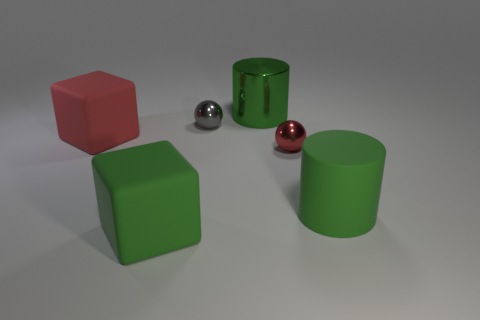Can you describe the lighting in this scene? The lighting in the scene appears to be soft and diffused, coming from above, as indicated by the soft shadows under the objects which suggest an overhead light source, possibly a softbox or an environment light. Could this be a natural or artificial light source? Given the controlled shadows and the lack of variance in the lighting, it's more likely to be an artificial source, as natural light often brings a more dynamic range of light and shadow. 